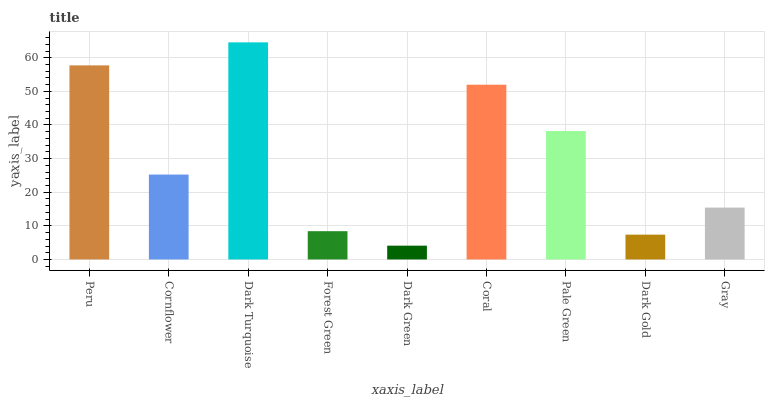Is Dark Green the minimum?
Answer yes or no. Yes. Is Dark Turquoise the maximum?
Answer yes or no. Yes. Is Cornflower the minimum?
Answer yes or no. No. Is Cornflower the maximum?
Answer yes or no. No. Is Peru greater than Cornflower?
Answer yes or no. Yes. Is Cornflower less than Peru?
Answer yes or no. Yes. Is Cornflower greater than Peru?
Answer yes or no. No. Is Peru less than Cornflower?
Answer yes or no. No. Is Cornflower the high median?
Answer yes or no. Yes. Is Cornflower the low median?
Answer yes or no. Yes. Is Forest Green the high median?
Answer yes or no. No. Is Peru the low median?
Answer yes or no. No. 